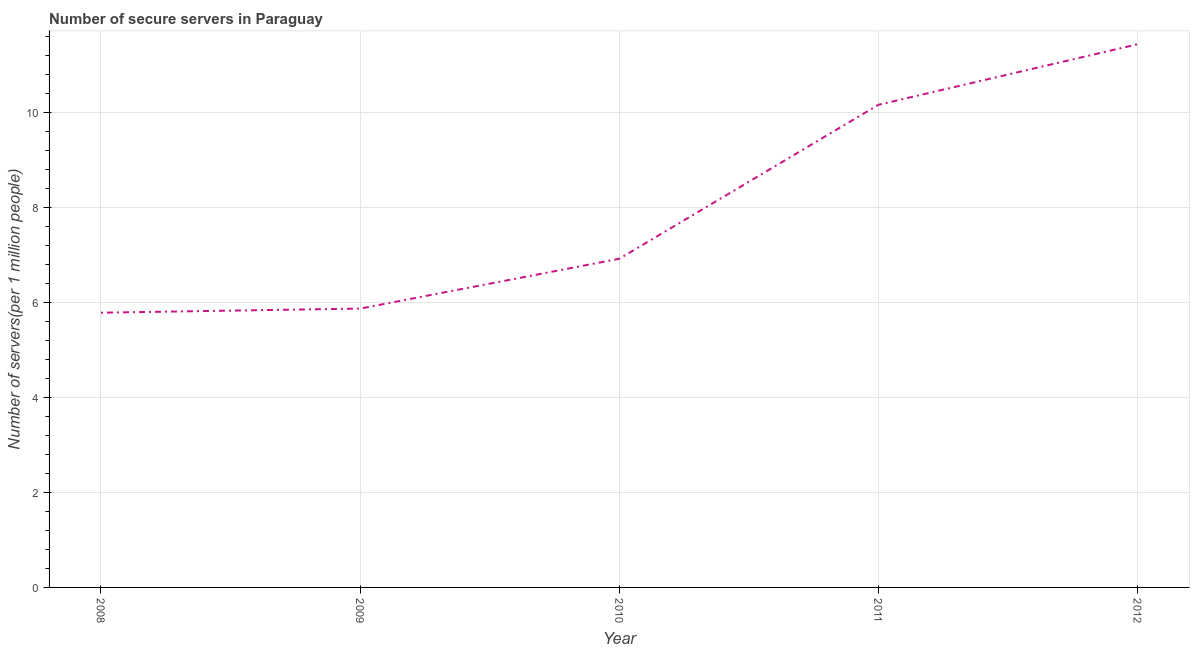What is the number of secure internet servers in 2008?
Your response must be concise. 5.79. Across all years, what is the maximum number of secure internet servers?
Your answer should be very brief. 11.44. Across all years, what is the minimum number of secure internet servers?
Make the answer very short. 5.79. In which year was the number of secure internet servers minimum?
Make the answer very short. 2008. What is the sum of the number of secure internet servers?
Provide a succinct answer. 40.2. What is the difference between the number of secure internet servers in 2010 and 2012?
Ensure brevity in your answer.  -4.52. What is the average number of secure internet servers per year?
Offer a terse response. 8.04. What is the median number of secure internet servers?
Make the answer very short. 6.92. Do a majority of the years between 2009 and 2010 (inclusive) have number of secure internet servers greater than 4.8 ?
Provide a short and direct response. Yes. What is the ratio of the number of secure internet servers in 2010 to that in 2012?
Make the answer very short. 0.61. Is the number of secure internet servers in 2008 less than that in 2011?
Provide a short and direct response. Yes. What is the difference between the highest and the second highest number of secure internet servers?
Your answer should be very brief. 1.27. Is the sum of the number of secure internet servers in 2008 and 2011 greater than the maximum number of secure internet servers across all years?
Ensure brevity in your answer.  Yes. What is the difference between the highest and the lowest number of secure internet servers?
Make the answer very short. 5.66. In how many years, is the number of secure internet servers greater than the average number of secure internet servers taken over all years?
Your answer should be very brief. 2. Does the number of secure internet servers monotonically increase over the years?
Your response must be concise. Yes. What is the difference between two consecutive major ticks on the Y-axis?
Give a very brief answer. 2. Are the values on the major ticks of Y-axis written in scientific E-notation?
Your response must be concise. No. Does the graph contain grids?
Ensure brevity in your answer.  Yes. What is the title of the graph?
Your answer should be very brief. Number of secure servers in Paraguay. What is the label or title of the Y-axis?
Your response must be concise. Number of servers(per 1 million people). What is the Number of servers(per 1 million people) of 2008?
Your answer should be very brief. 5.79. What is the Number of servers(per 1 million people) in 2009?
Keep it short and to the point. 5.87. What is the Number of servers(per 1 million people) of 2010?
Provide a short and direct response. 6.92. What is the Number of servers(per 1 million people) of 2011?
Your answer should be compact. 10.17. What is the Number of servers(per 1 million people) of 2012?
Offer a very short reply. 11.44. What is the difference between the Number of servers(per 1 million people) in 2008 and 2009?
Make the answer very short. -0.09. What is the difference between the Number of servers(per 1 million people) in 2008 and 2010?
Provide a short and direct response. -1.14. What is the difference between the Number of servers(per 1 million people) in 2008 and 2011?
Your answer should be compact. -4.38. What is the difference between the Number of servers(per 1 million people) in 2008 and 2012?
Your answer should be compact. -5.66. What is the difference between the Number of servers(per 1 million people) in 2009 and 2010?
Your answer should be compact. -1.05. What is the difference between the Number of servers(per 1 million people) in 2009 and 2011?
Provide a short and direct response. -4.29. What is the difference between the Number of servers(per 1 million people) in 2009 and 2012?
Give a very brief answer. -5.57. What is the difference between the Number of servers(per 1 million people) in 2010 and 2011?
Your answer should be compact. -3.24. What is the difference between the Number of servers(per 1 million people) in 2010 and 2012?
Give a very brief answer. -4.52. What is the difference between the Number of servers(per 1 million people) in 2011 and 2012?
Provide a short and direct response. -1.27. What is the ratio of the Number of servers(per 1 million people) in 2008 to that in 2010?
Make the answer very short. 0.84. What is the ratio of the Number of servers(per 1 million people) in 2008 to that in 2011?
Your answer should be compact. 0.57. What is the ratio of the Number of servers(per 1 million people) in 2008 to that in 2012?
Provide a short and direct response. 0.51. What is the ratio of the Number of servers(per 1 million people) in 2009 to that in 2010?
Give a very brief answer. 0.85. What is the ratio of the Number of servers(per 1 million people) in 2009 to that in 2011?
Make the answer very short. 0.58. What is the ratio of the Number of servers(per 1 million people) in 2009 to that in 2012?
Offer a very short reply. 0.51. What is the ratio of the Number of servers(per 1 million people) in 2010 to that in 2011?
Your response must be concise. 0.68. What is the ratio of the Number of servers(per 1 million people) in 2010 to that in 2012?
Offer a very short reply. 0.6. What is the ratio of the Number of servers(per 1 million people) in 2011 to that in 2012?
Give a very brief answer. 0.89. 